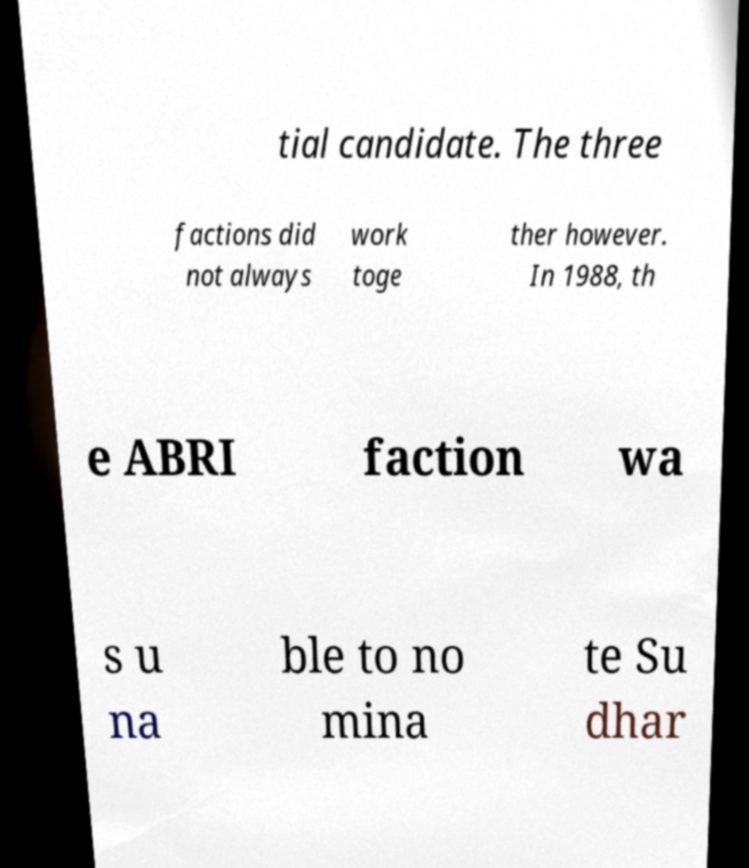I need the written content from this picture converted into text. Can you do that? tial candidate. The three factions did not always work toge ther however. In 1988, th e ABRI faction wa s u na ble to no mina te Su dhar 